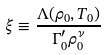<formula> <loc_0><loc_0><loc_500><loc_500>\xi \equiv \frac { \Lambda ( \rho _ { 0 } , T _ { 0 } ) } { \Gamma _ { 0 } ^ { \prime } \rho _ { 0 } ^ { \nu } }</formula> 